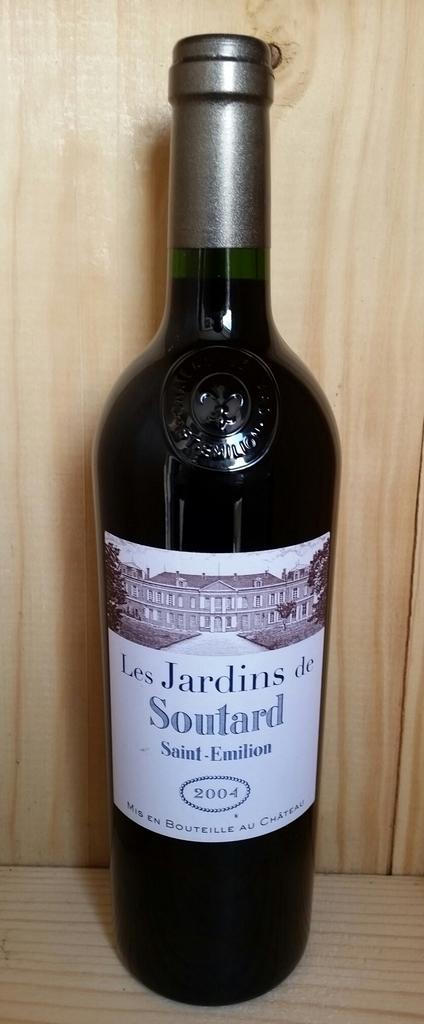Is this bottle from 2004?
Offer a very short reply. Yes. What is this wine?
Offer a very short reply. Soutard. 